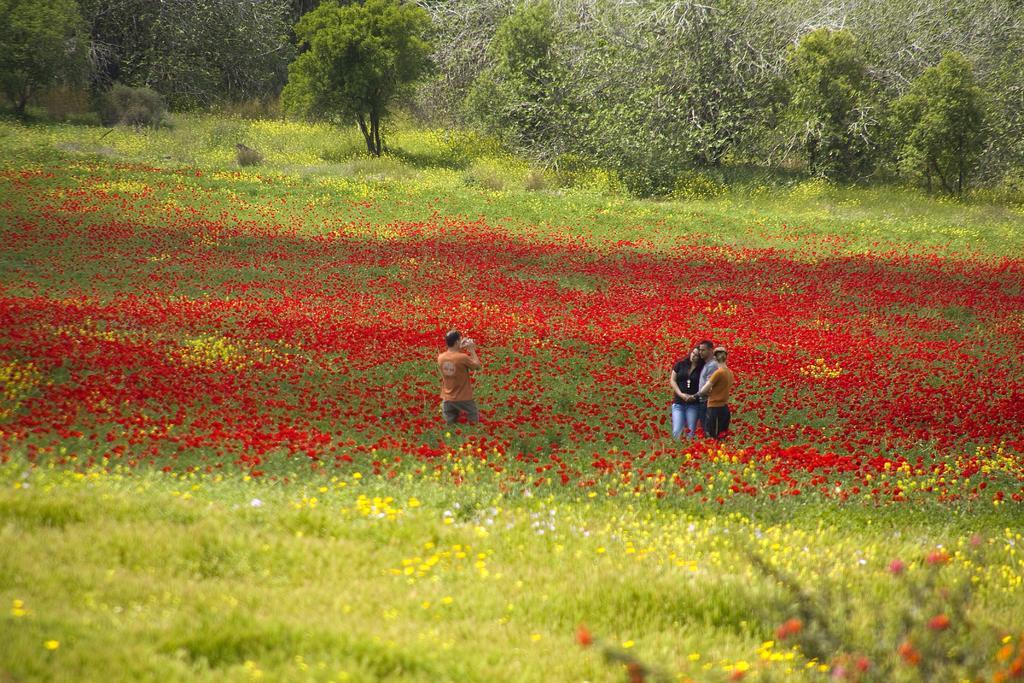In one or two sentences, can you explain what this image depicts? Land is covered with plants and flowers. These people are standing. This man is holding an object. Background there are trees. 